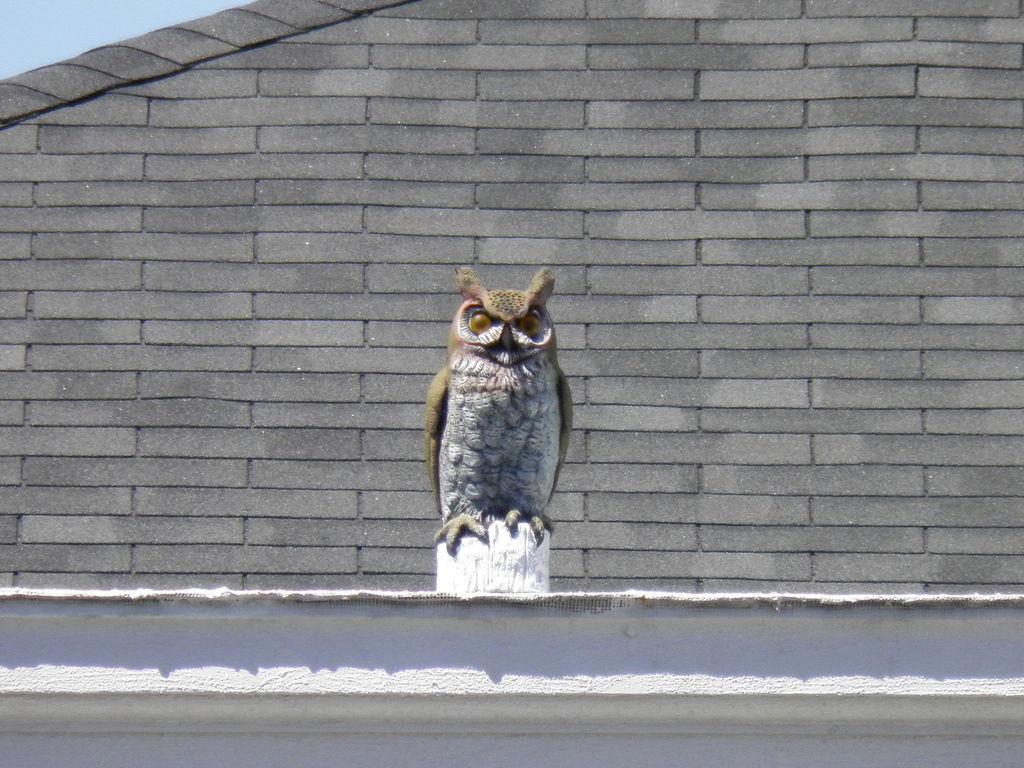How would you summarize this image in a sentence or two? In this image I can see a sculpture of an owl in the front and in the background I can see the wall. 